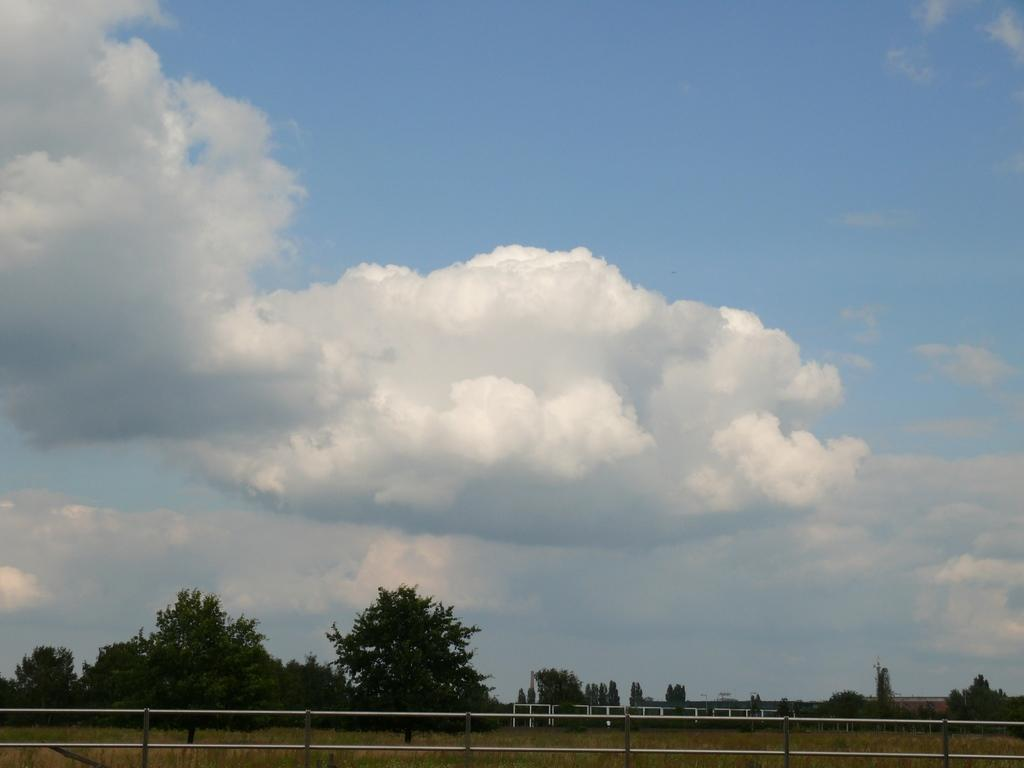What type of surface is on the floor in the image? There is grass on the floor in the image. What can be seen in the background of the image? There are trees in the background of the image. What is the condition of the sky in the image? The sky is clear in the image. What type of meat is being served on the grass in the image? There is no meat present in the image; it features grass on the floor and trees in the background. 